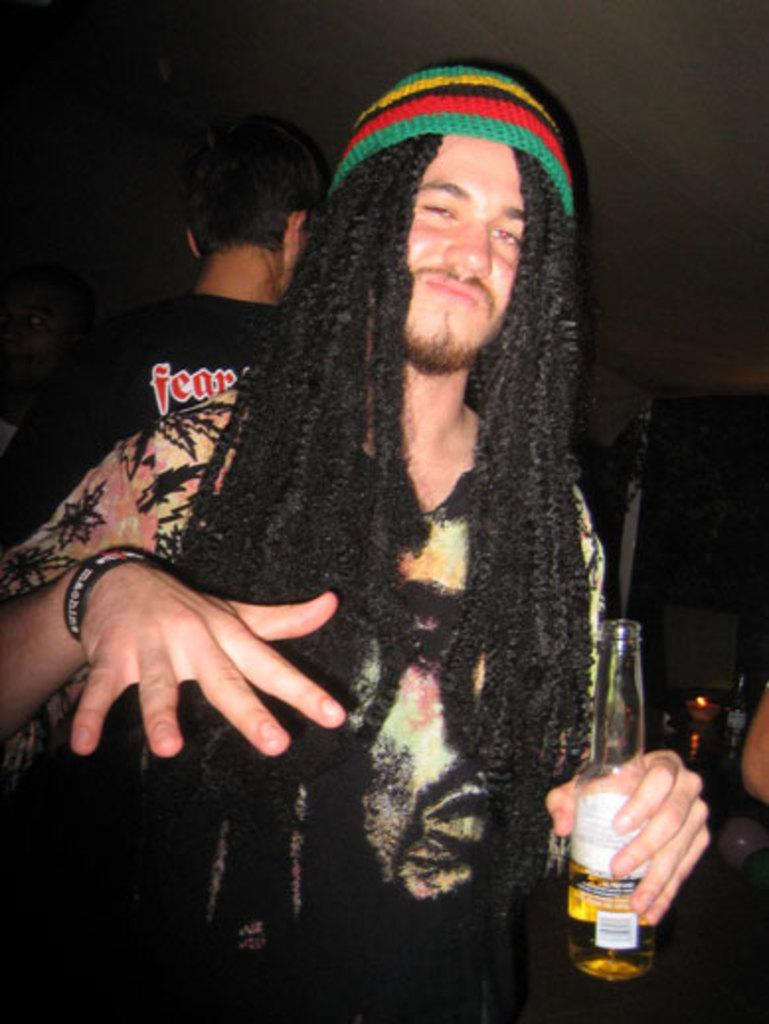What is the person in the image doing? The person in the image is standing and holding a bottle. Can you describe the position of the second person in the image? The second person is behind the first person. What type of liquid is being poured from the bottle in the image? There is no indication of any liquid being poured from the bottle in the image. Can you see any coal in the image? There is no coal present in the image. 